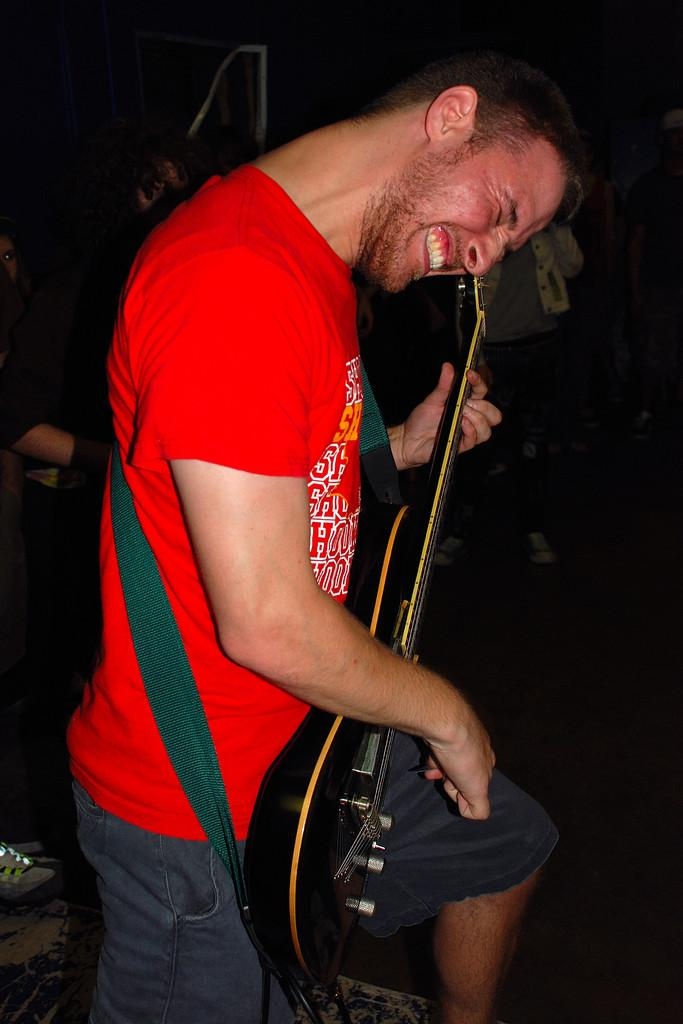What is the main activity of the person in the image? The person in the image is standing and playing a guitar. Can you describe the position of the second person in the image? There is another person beside the person playing the guitar. What object can be seen at the left bottom of the image? There is a shoe at the left bottom of the image. How many people are standing in the image? There are two people standing in the image, one playing the guitar and another on the right side. What type of building is visible in the image? There is no building present in the image. Can you describe the shape of the square in the image? There is no square present in the image. 